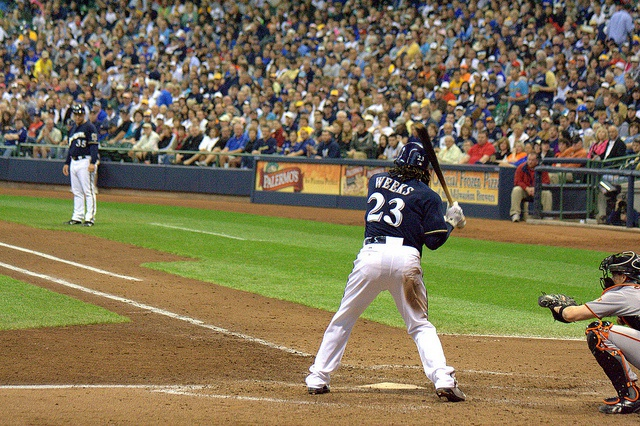Describe the objects in this image and their specific colors. I can see people in black, gray, and olive tones, people in black, white, gray, and darkgray tones, people in black, darkgray, gray, and lightgray tones, people in black, lavender, navy, and darkgray tones, and people in black, maroon, gray, and tan tones in this image. 